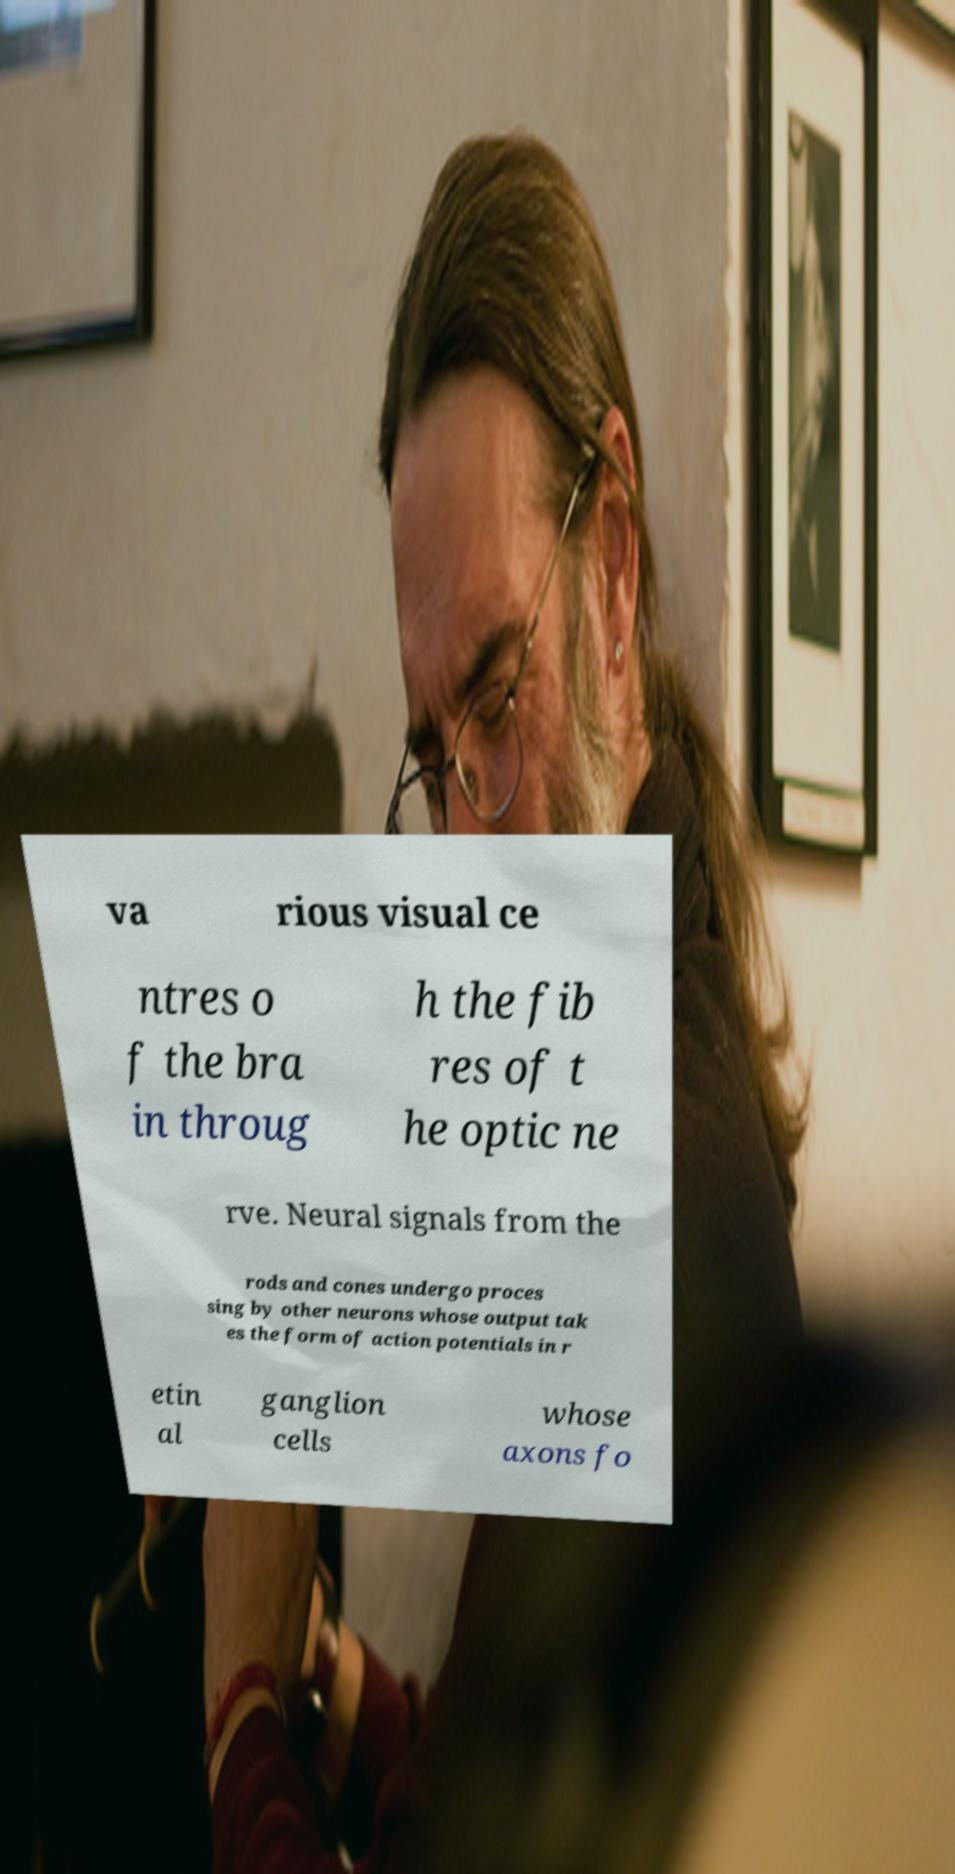Please read and relay the text visible in this image. What does it say? va rious visual ce ntres o f the bra in throug h the fib res of t he optic ne rve. Neural signals from the rods and cones undergo proces sing by other neurons whose output tak es the form of action potentials in r etin al ganglion cells whose axons fo 